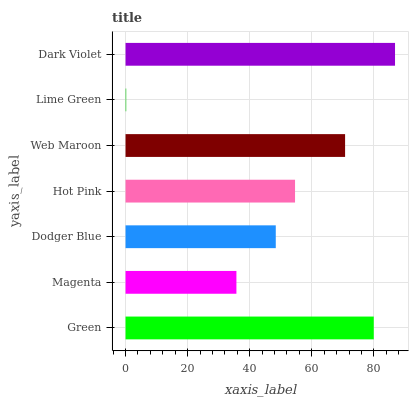Is Lime Green the minimum?
Answer yes or no. Yes. Is Dark Violet the maximum?
Answer yes or no. Yes. Is Magenta the minimum?
Answer yes or no. No. Is Magenta the maximum?
Answer yes or no. No. Is Green greater than Magenta?
Answer yes or no. Yes. Is Magenta less than Green?
Answer yes or no. Yes. Is Magenta greater than Green?
Answer yes or no. No. Is Green less than Magenta?
Answer yes or no. No. Is Hot Pink the high median?
Answer yes or no. Yes. Is Hot Pink the low median?
Answer yes or no. Yes. Is Green the high median?
Answer yes or no. No. Is Dark Violet the low median?
Answer yes or no. No. 